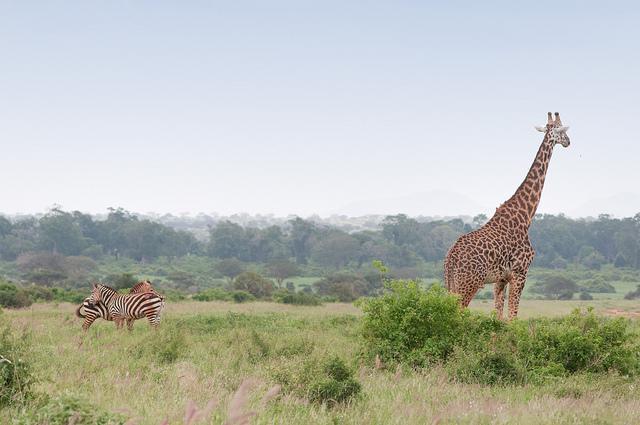How many giraffe are standing in the field?
Give a very brief answer. 1. 